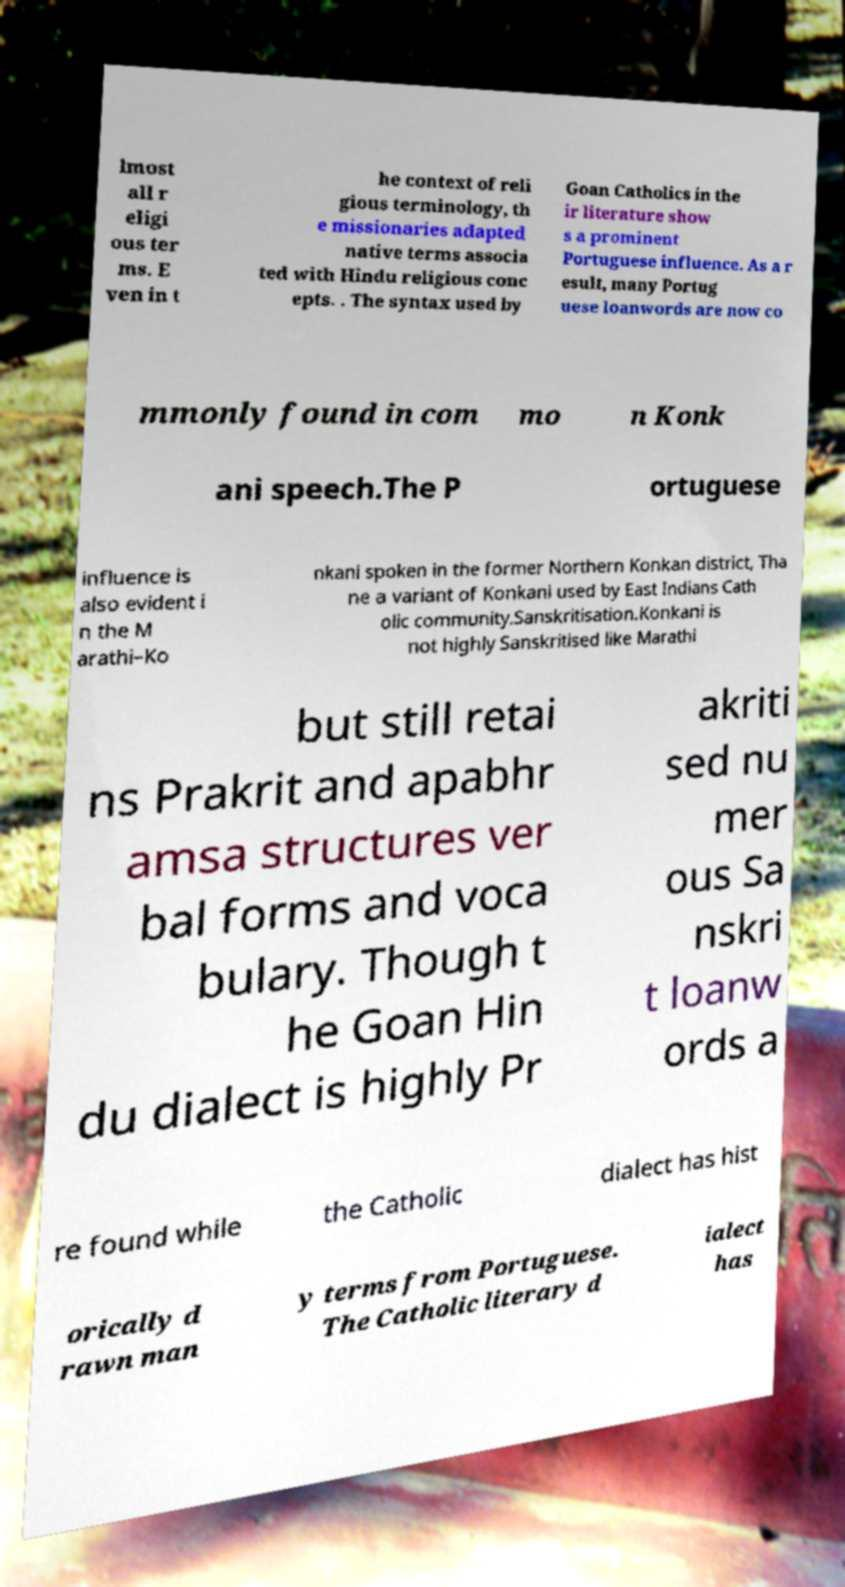Could you extract and type out the text from this image? lmost all r eligi ous ter ms. E ven in t he context of reli gious terminology, th e missionaries adapted native terms associa ted with Hindu religious conc epts. . The syntax used by Goan Catholics in the ir literature show s a prominent Portuguese influence. As a r esult, many Portug uese loanwords are now co mmonly found in com mo n Konk ani speech.The P ortuguese influence is also evident i n the M arathi–Ko nkani spoken in the former Northern Konkan district, Tha ne a variant of Konkani used by East Indians Cath olic community.Sanskritisation.Konkani is not highly Sanskritised like Marathi but still retai ns Prakrit and apabhr amsa structures ver bal forms and voca bulary. Though t he Goan Hin du dialect is highly Pr akriti sed nu mer ous Sa nskri t loanw ords a re found while the Catholic dialect has hist orically d rawn man y terms from Portuguese. The Catholic literary d ialect has 